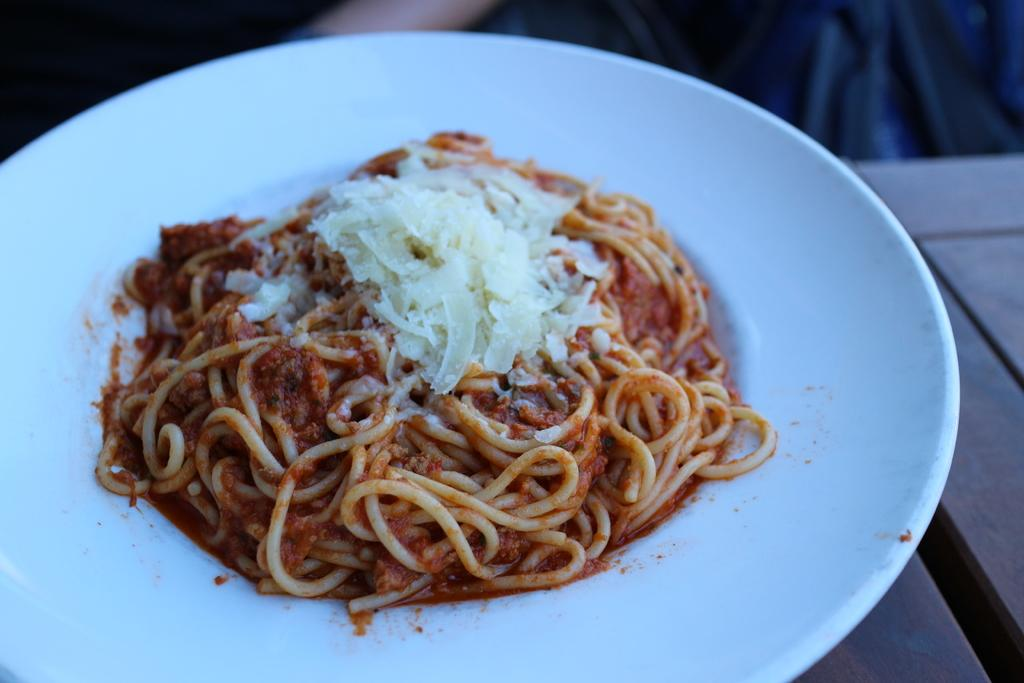What is on the plate in the image? There are noodles on the plate in the image. What color is the plate in the image? The plate in the image is white. What other white object can be seen on the plate? There is a white color thing on the plate, possibly a utensil or napkin. What is the color of the surface beneath the plate in the image? The surface beneath the plate in the image is brown. Can you tell me how many plants are visible in the image? There is no plant visible in the image; it only shows a plate with noodles, a white object, and a brown surface. 